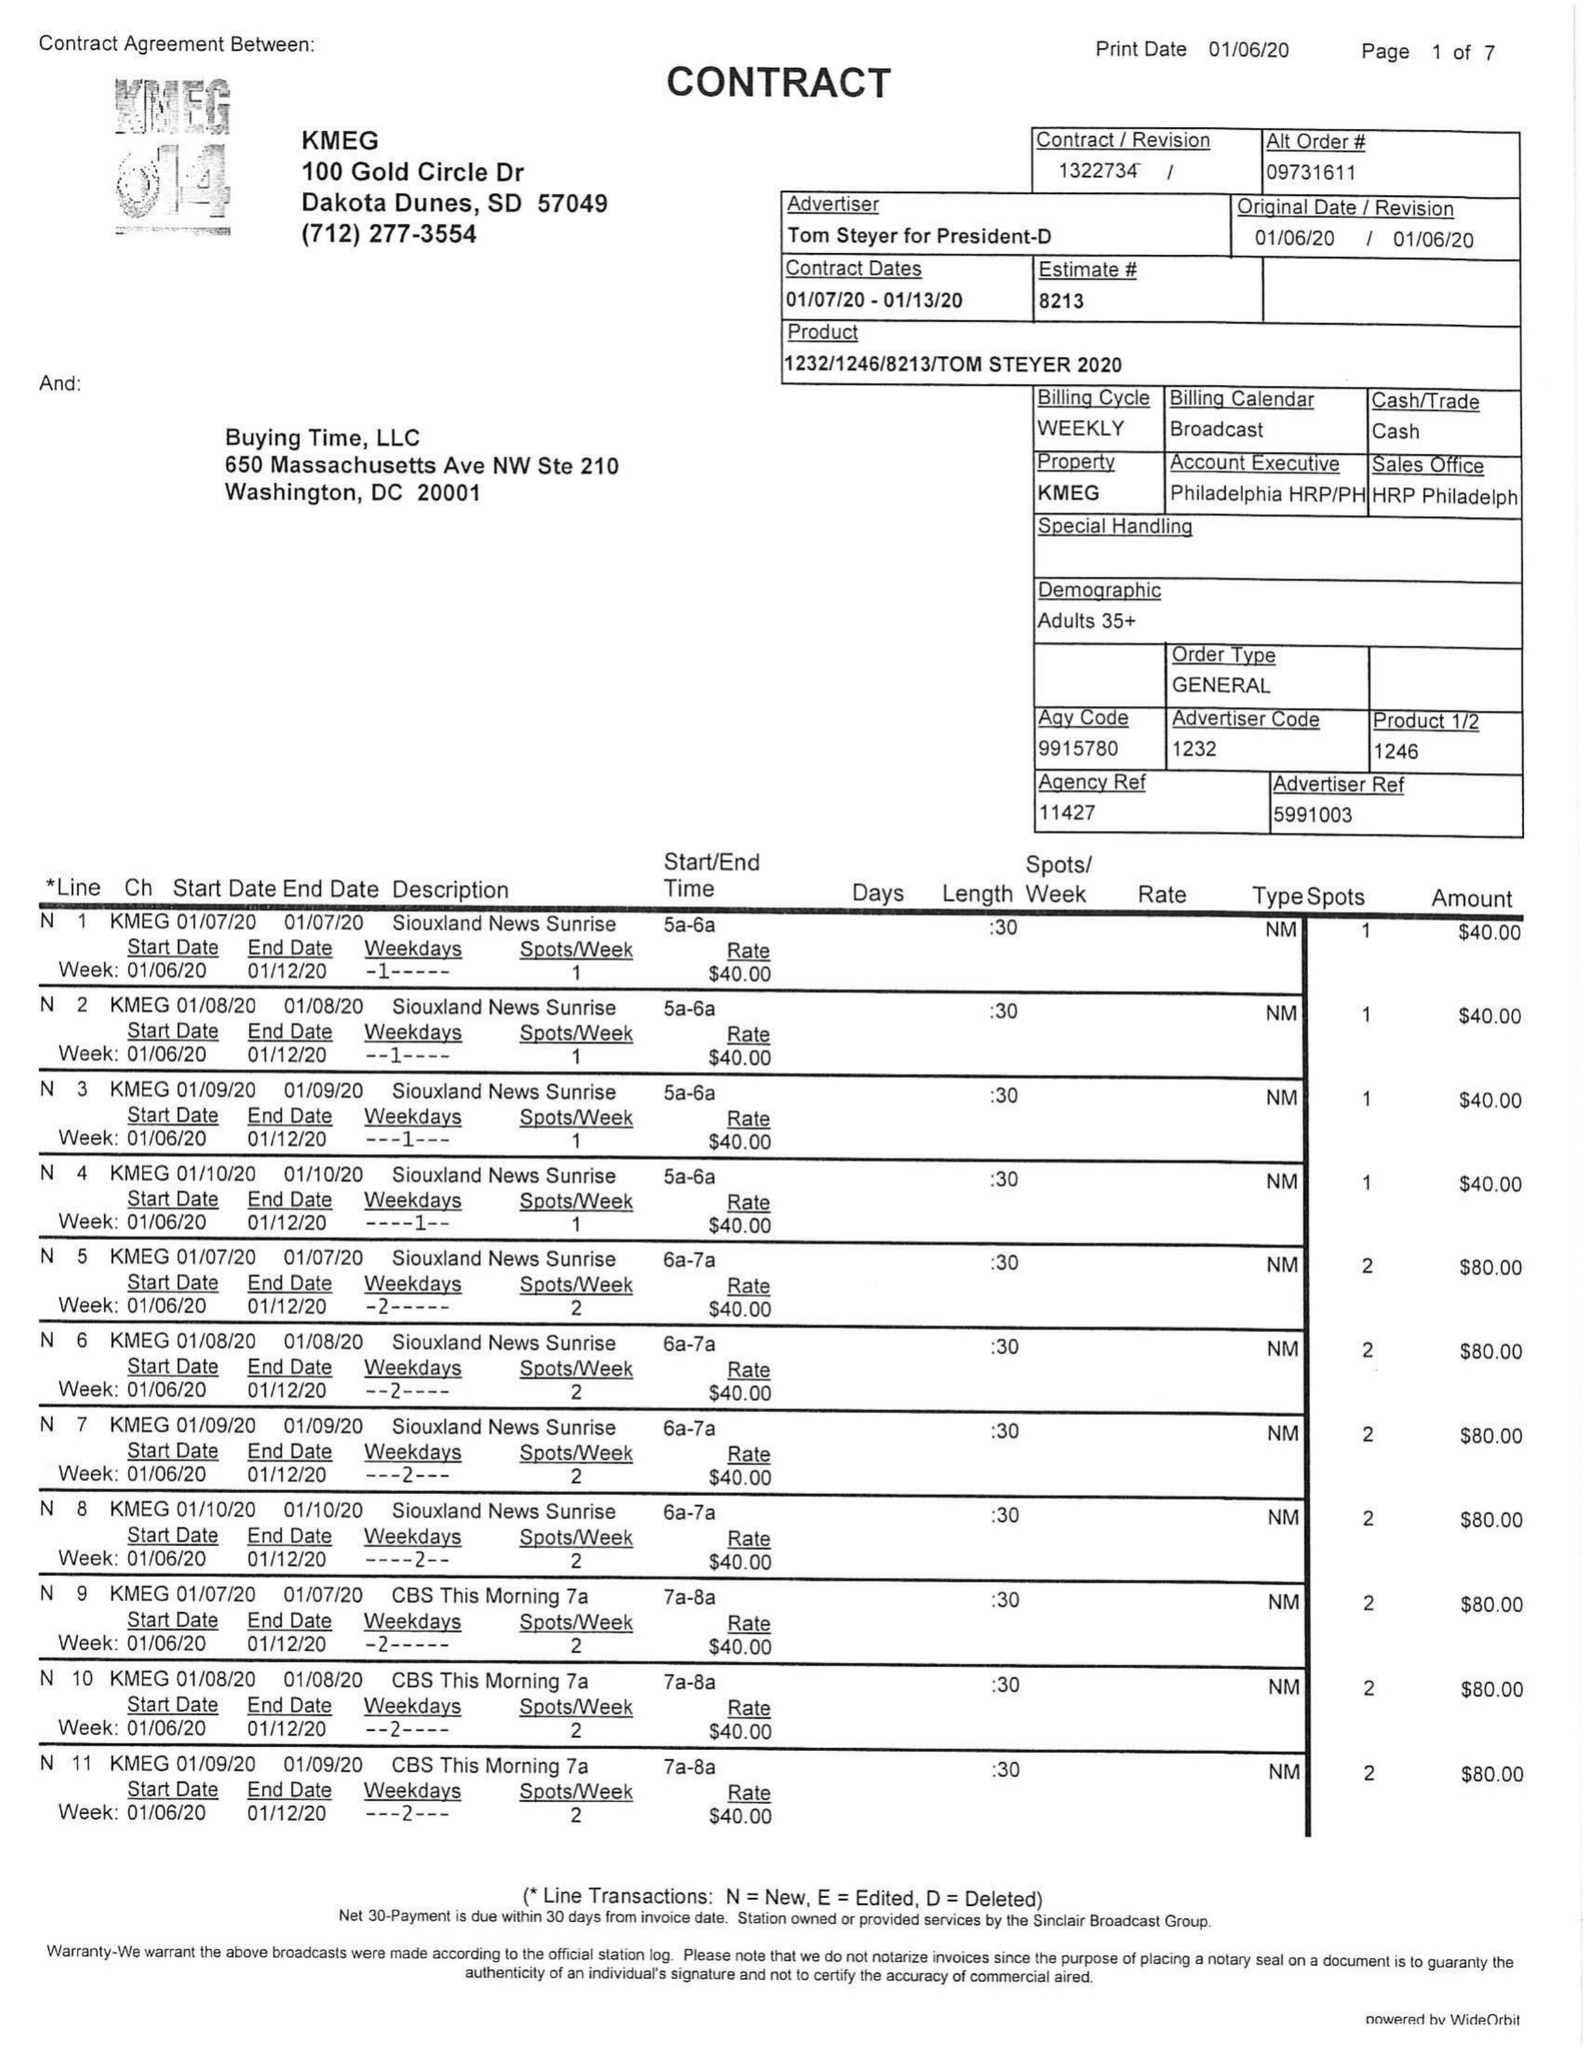What is the value for the flight_from?
Answer the question using a single word or phrase. 01/07/20 